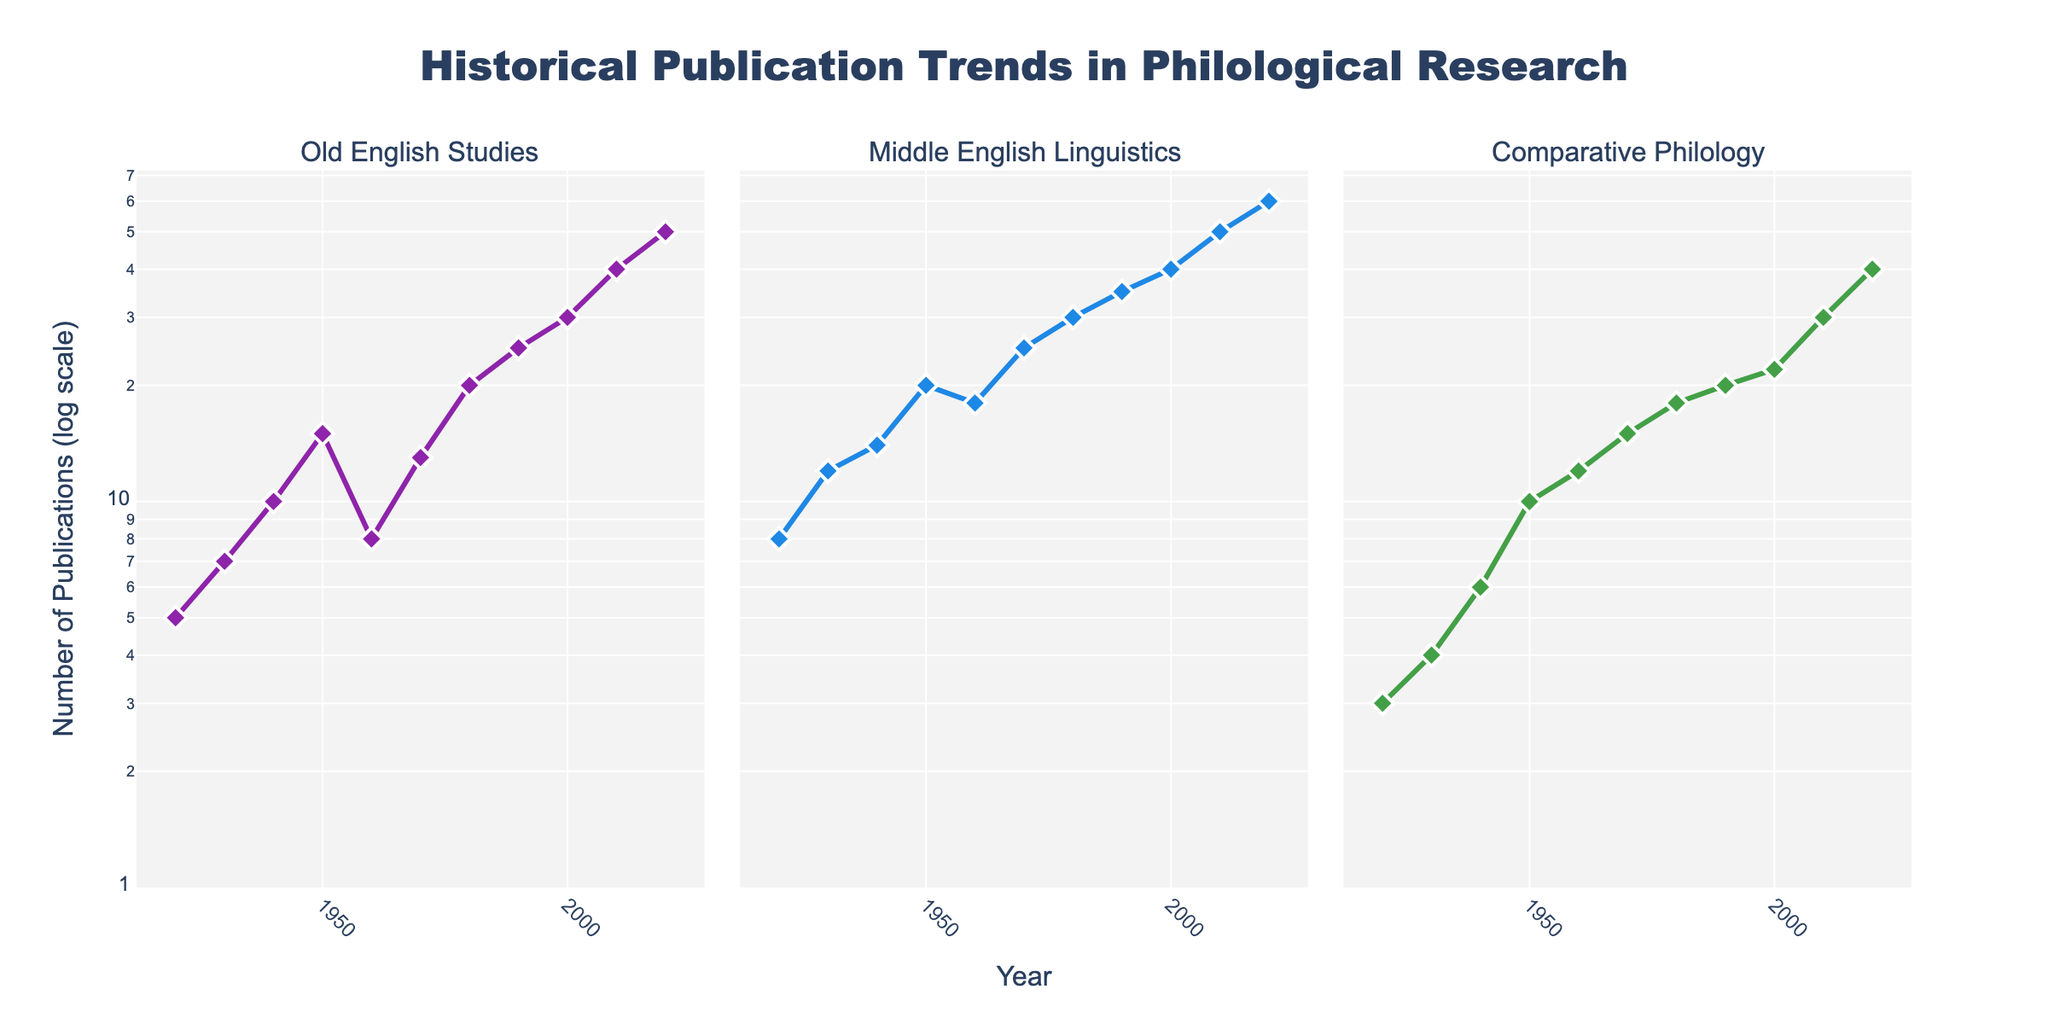What is the maximum number of publications for Middle English Linguistics in any year? The highest point on the Middle English Linguistics subplot reaches 60 publications, as seen for the year 2020.
Answer: 60 What is the general trend in publications for Old English Studies from 1920 to 2020? From 1920 to 2020, Old English Studies shows a general upward trend with some fluctuations, culminating in 50 publications in 2020.
Answer: Upward trend Compare the number of publications for Middle English Linguistics and Comparative Philology in 2000. Which has more? In the year 2000, Middle English Linguistics has 40 publications, whereas Comparative Philology has 22 publications. Middle English Linguistics has more.
Answer: Middle English Linguistics Which category experienced the largest increase in the number of publications from 2010 to 2020? By calculating the difference in publications from 2010 to 2020 for each category: Old English Studies (50-40=10), Middle English Linguistics (60-50=10), Comparative Philology (40-30=10). All categories increased by 10.
Answer: All categories What is the publication trend for Comparative Philology from 1920 to 1950? Comparative Philology shows a gradual increase in publications from 3 in 1920, 4 in 1930, 6 in 1940 to 10 in 1950.
Answer: Gradual increase During which decade did Old English Studies see a decrease in publication numbers? Between the 1950s and 1960s, Old English Studies saw a decrease from 15 to 8 publications.
Answer: 1950s-1960s Which year had the lowest number of publications across all categories combined? In 1920, the combined number of publications is (5 + 8 + 3) = 16, the lowest compared to other years.
Answer: 1920 In which year do all three categories have their maximum number of publications? In 2020, all three categories reach their maximum publications: Old English Studies (50), Middle English Linguistics (60), and Comparative Philology (40).
Answer: 2020 How did the number of publications for Middle English Linguistics change between 1930 and 1940? Middle English Linguistics publications increased from 12 in 1930 to 14 in 1940.
Answer: Increased by 2 Using the log scale, which category has the least variation in publication numbers over time? By examining the log plot lines, Comparative Philology shows less variation in publication numbers compared to Old and Middle English Studies.
Answer: Comparative Philology 